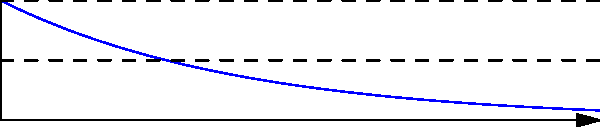In an ADSR envelope model, the decay phase starts at an amplitude of 1 and ends at the sustain level of 0.5. If the decay phase lasts for 1 second, what is the decay rate (λ) in the exponential decay function $A(t) = A_0e^{-λt}$, where $A_0$ is the initial amplitude and $t$ is time in seconds? To find the decay rate (λ), we can use the exponential decay function:

$A(t) = A_0e^{-λt}$

Where:
$A(t)$ is the amplitude at time $t$
$A_0$ is the initial amplitude (1 in this case)
$λ$ is the decay rate
$t$ is the time (1 second for the decay phase)

We know:
1. Initial amplitude $A_0 = 1$
2. Final amplitude $A(1) = 0.5$ (sustain level)
3. Time $t = 1$ second

Plugging these values into the equation:

$0.5 = 1 \cdot e^{-λ \cdot 1}$

Simplifying:

$0.5 = e^{-λ}$

Taking the natural logarithm of both sides:

$\ln(0.5) = -λ$

Solving for λ:

$λ = -\ln(0.5) = \ln(2) \approx 0.693$

Therefore, the decay rate λ is approximately 0.693 per second.
Answer: $\ln(2) \approx 0.693$ per second 